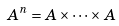<formula> <loc_0><loc_0><loc_500><loc_500>A ^ { n } = A \times \dots \times A</formula> 